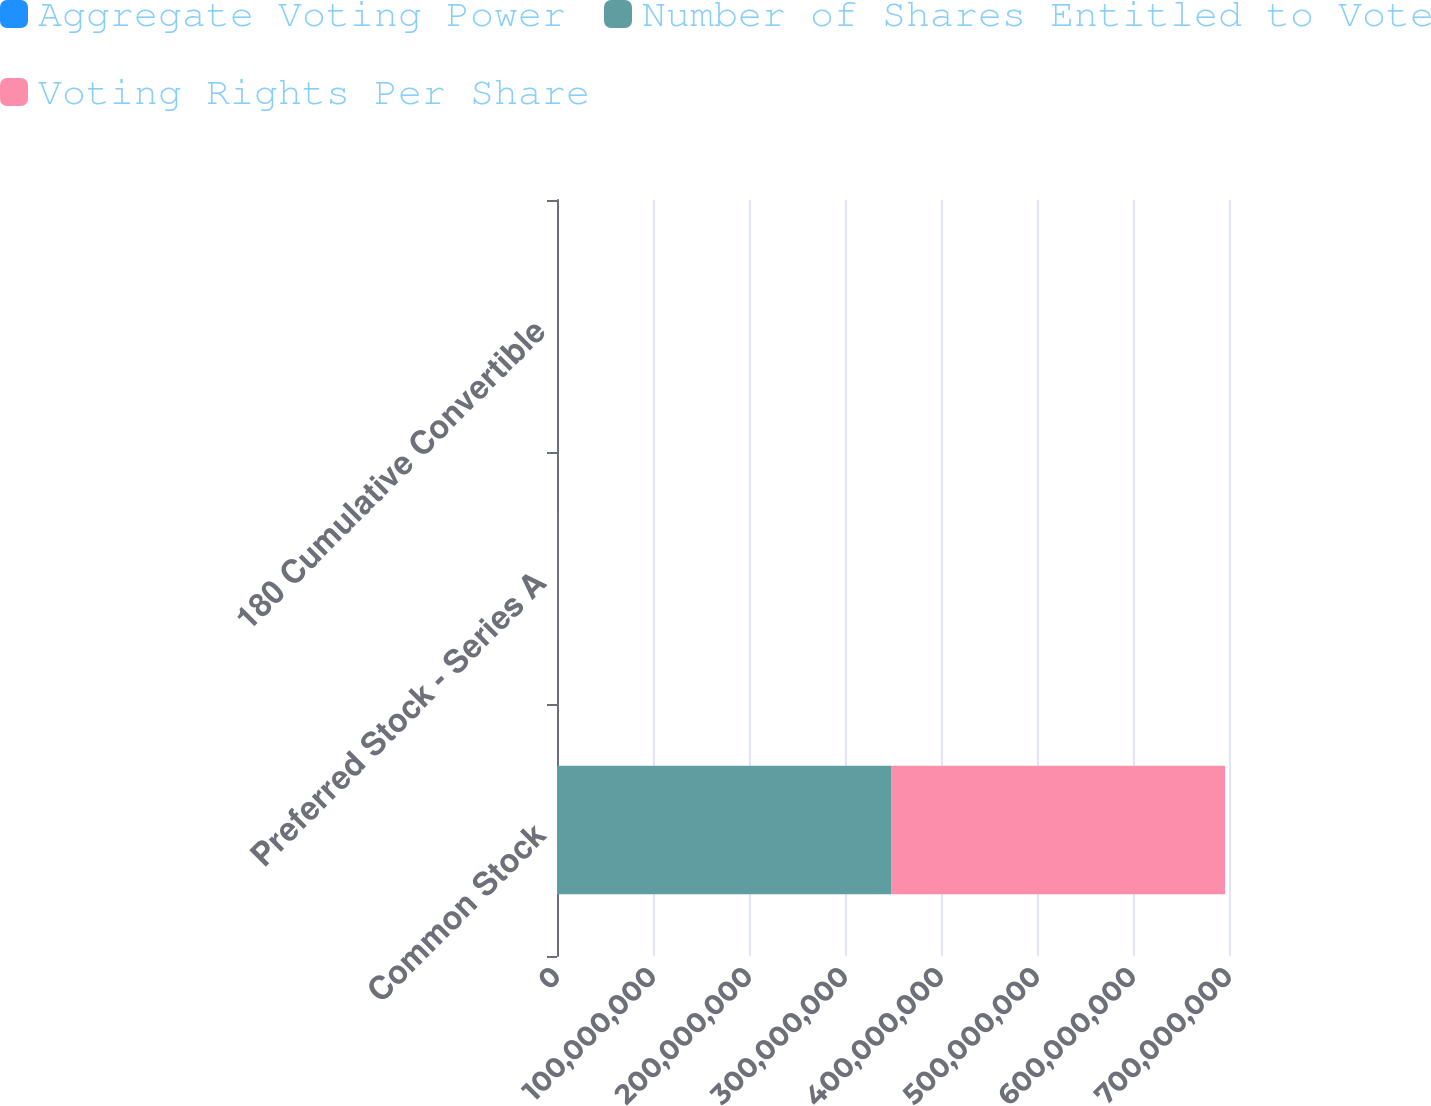<chart> <loc_0><loc_0><loc_500><loc_500><stacked_bar_chart><ecel><fcel>Common Stock<fcel>Preferred Stock - Series A<fcel>180 Cumulative Convertible<nl><fcel>Aggregate Voting Power<fcel>1<fcel>8<fcel>8<nl><fcel>Number of Shares Entitled to Vote<fcel>3.4796e+08<fcel>6540<fcel>1137<nl><fcel>Voting Rights Per Share<fcel>3.4796e+08<fcel>52320<fcel>9096<nl></chart> 